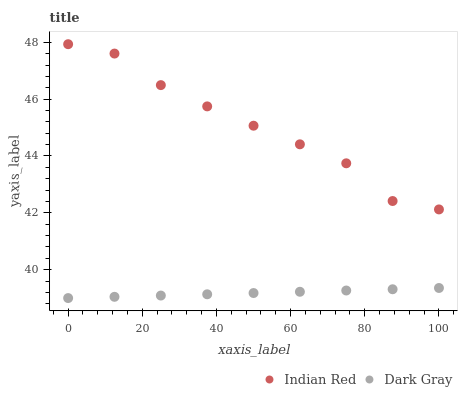Does Dark Gray have the minimum area under the curve?
Answer yes or no. Yes. Does Indian Red have the maximum area under the curve?
Answer yes or no. Yes. Does Indian Red have the minimum area under the curve?
Answer yes or no. No. Is Dark Gray the smoothest?
Answer yes or no. Yes. Is Indian Red the roughest?
Answer yes or no. Yes. Is Indian Red the smoothest?
Answer yes or no. No. Does Dark Gray have the lowest value?
Answer yes or no. Yes. Does Indian Red have the lowest value?
Answer yes or no. No. Does Indian Red have the highest value?
Answer yes or no. Yes. Is Dark Gray less than Indian Red?
Answer yes or no. Yes. Is Indian Red greater than Dark Gray?
Answer yes or no. Yes. Does Dark Gray intersect Indian Red?
Answer yes or no. No. 